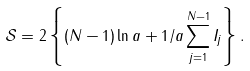<formula> <loc_0><loc_0><loc_500><loc_500>\mathcal { S } = 2 \left \{ ( N - 1 ) \ln a + 1 / a \sum _ { j = 1 } ^ { N - 1 } I _ { j } \right \} .</formula> 